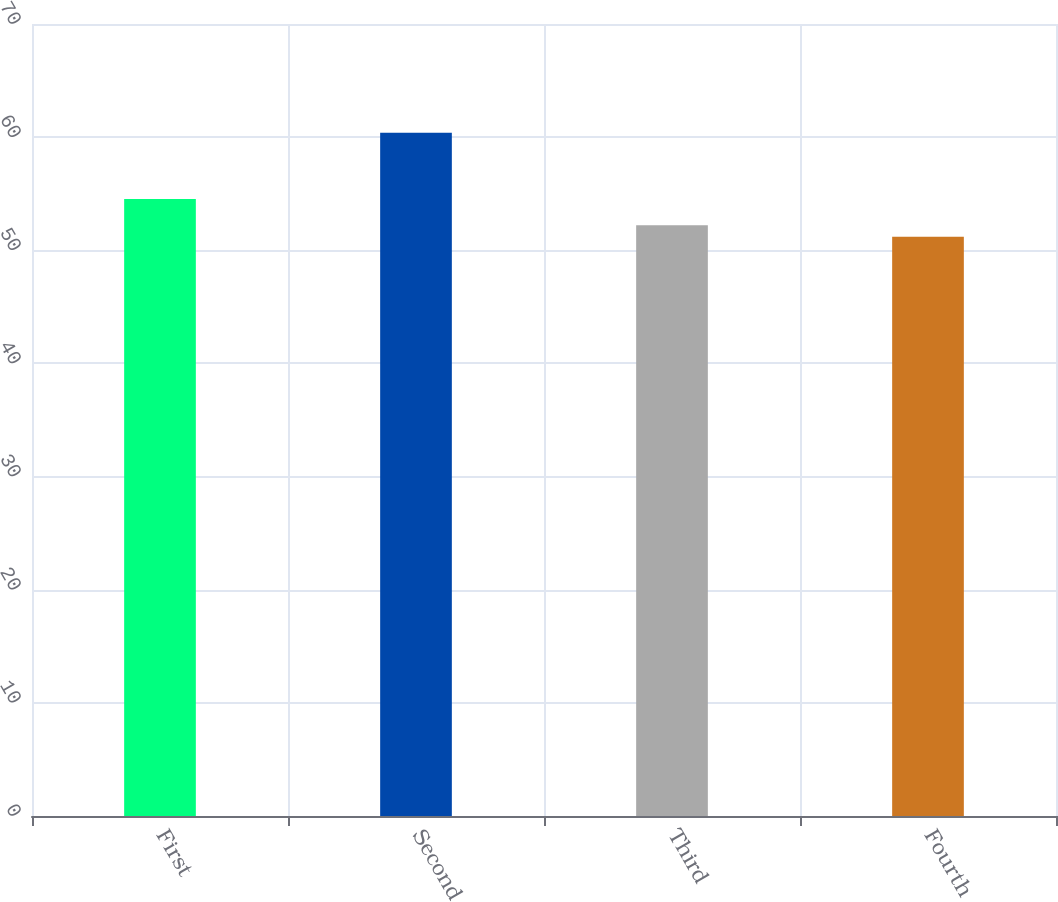Convert chart. <chart><loc_0><loc_0><loc_500><loc_500><bar_chart><fcel>First<fcel>Second<fcel>Third<fcel>Fourth<nl><fcel>54.53<fcel>60.38<fcel>52.21<fcel>51.2<nl></chart> 